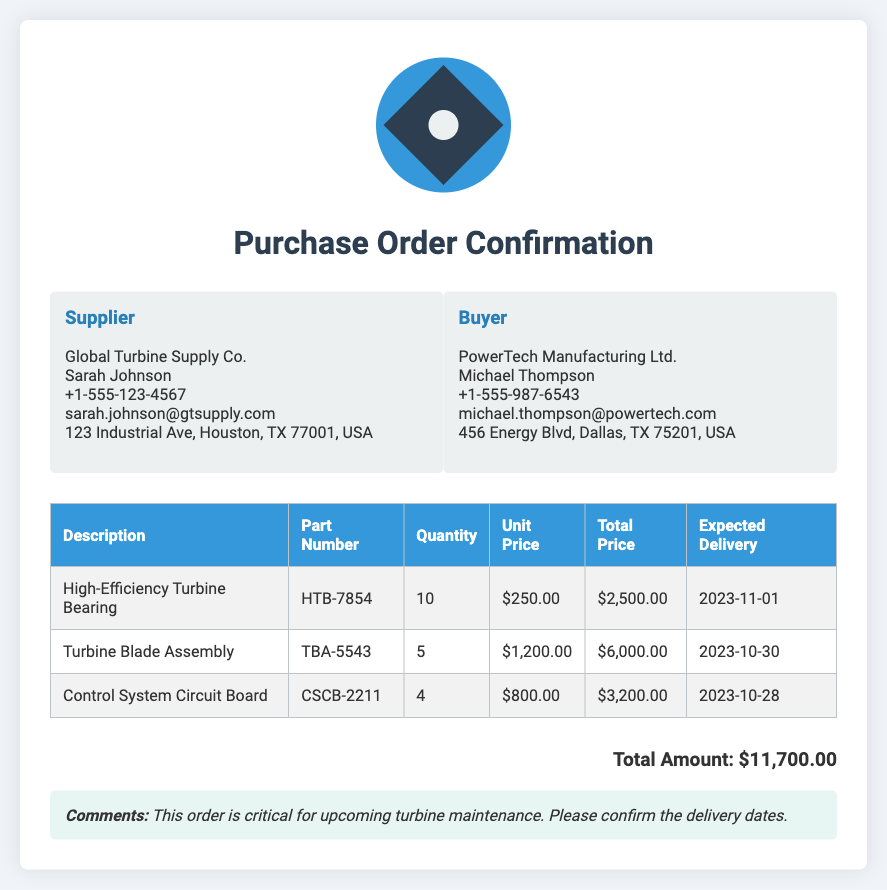what is the supplier's name? The supplier's name listed in the document is Global Turbine Supply Co.
Answer: Global Turbine Supply Co what is the buyer's email address? The buyer's email address provided in the document is michael.thompson@powertech.com.
Answer: michael.thompson@powertech.com what is the expected delivery date for the Control System Circuit Board? The expected delivery date for the Control System Circuit Board is shown in the document as 2023-10-28.
Answer: 2023-10-28 how many Turbine Blade Assemblies are ordered? The number of Turbine Blade Assemblies ordered can be found in the table, which states 5.
Answer: 5 what is the total amount for the order? The total amount is summarized at the end of the document, which indicates $11,700.00.
Answer: $11,700.00 who is the contact person for the supplier? The contact person for the supplier is explicitly mentioned in the document as Sarah Johnson.
Answer: Sarah Johnson how much does each High-Efficiency Turbine Bearing cost? Each High-Efficiency Turbine Bearing's unit price is detailed as $250.00 in the document.
Answer: $250.00 what is the significance of this order as noted in the comments? The comments section highlights that this order is critical for upcoming turbine maintenance.
Answer: critical for upcoming turbine maintenance 